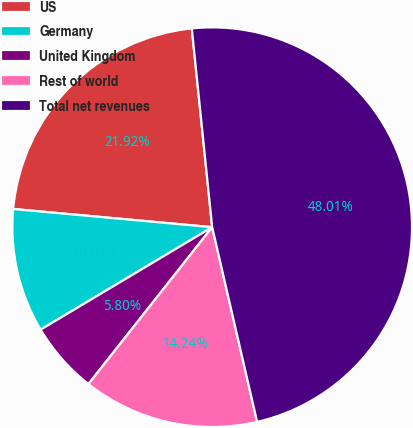Convert chart. <chart><loc_0><loc_0><loc_500><loc_500><pie_chart><fcel>US<fcel>Germany<fcel>United Kingdom<fcel>Rest of world<fcel>Total net revenues<nl><fcel>21.92%<fcel>10.02%<fcel>5.8%<fcel>14.24%<fcel>48.01%<nl></chart> 